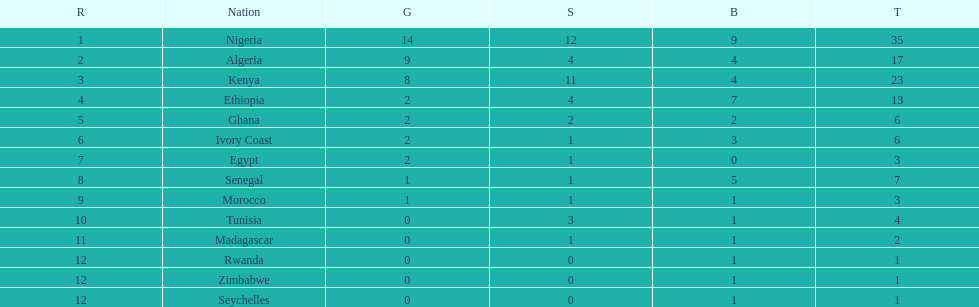What was the total number of medals the ivory coast won? 6. 